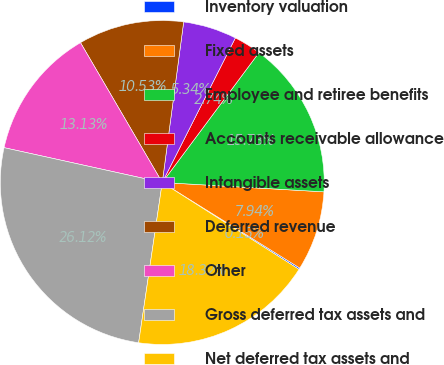Convert chart. <chart><loc_0><loc_0><loc_500><loc_500><pie_chart><fcel>Inventory valuation<fcel>Fixed assets<fcel>Employee and retiree benefits<fcel>Accounts receivable allowance<fcel>Intangible assets<fcel>Deferred revenue<fcel>Other<fcel>Gross deferred tax assets and<fcel>Net deferred tax assets and<nl><fcel>0.15%<fcel>7.94%<fcel>15.73%<fcel>2.74%<fcel>5.34%<fcel>10.53%<fcel>13.13%<fcel>26.12%<fcel>18.32%<nl></chart> 